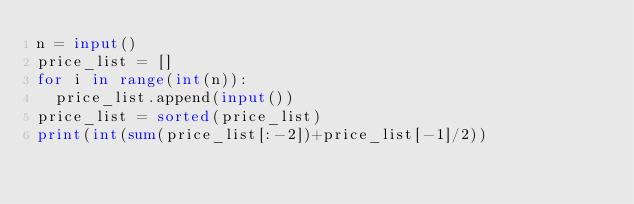Convert code to text. <code><loc_0><loc_0><loc_500><loc_500><_Python_>n = input()
price_list = []
for i in range(int(n)):
  price_list.append(input())
price_list = sorted(price_list)
print(int(sum(price_list[:-2])+price_list[-1]/2))</code> 